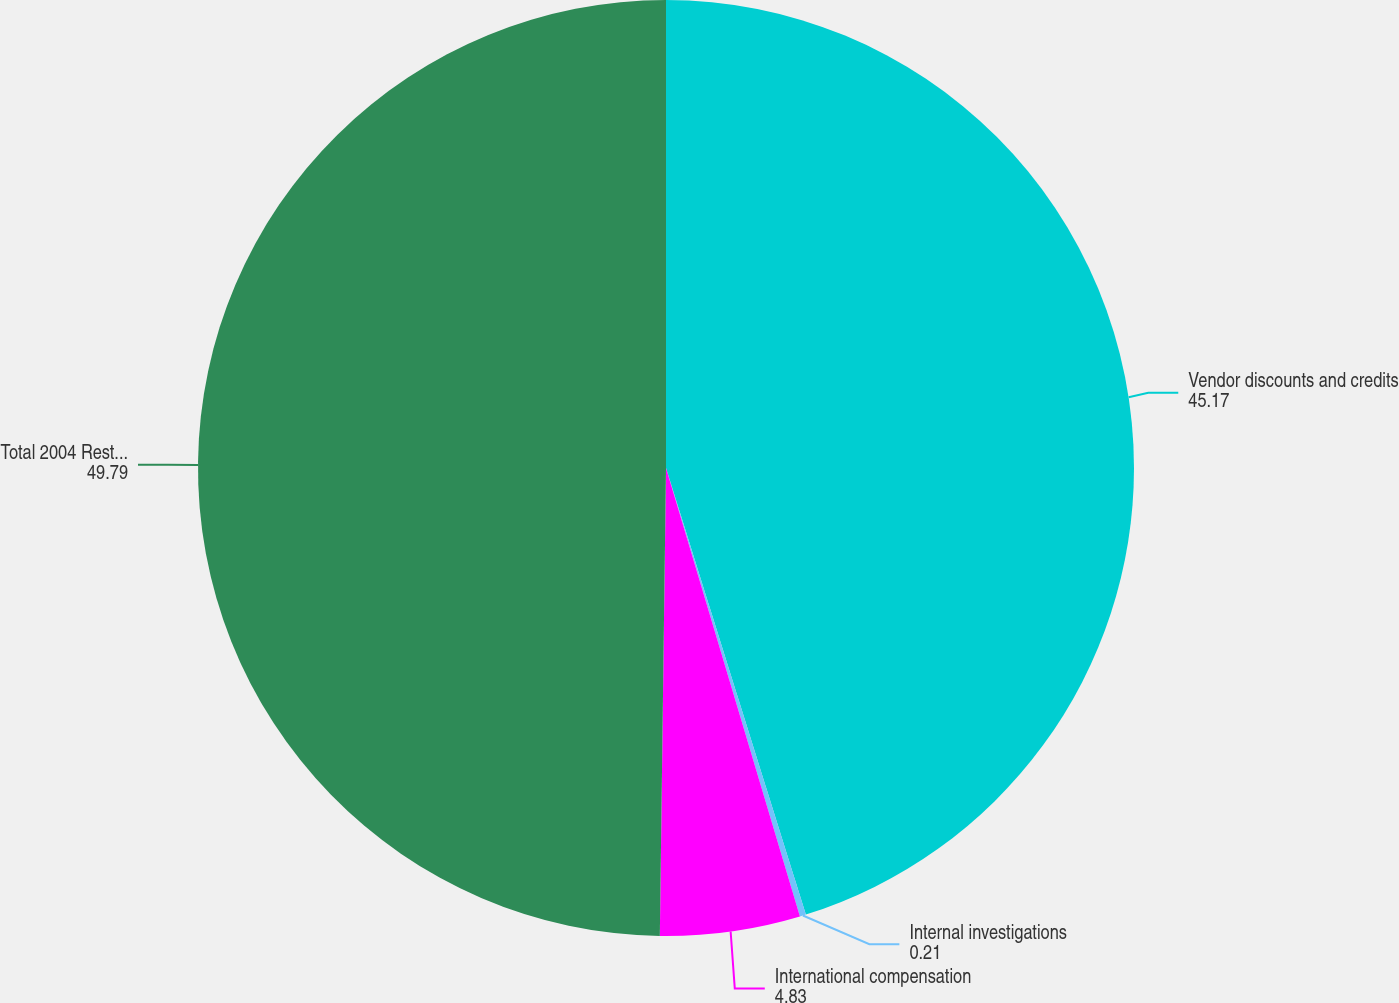Convert chart. <chart><loc_0><loc_0><loc_500><loc_500><pie_chart><fcel>Vendor discounts and credits<fcel>Internal investigations<fcel>International compensation<fcel>Total 2004 Restatement<nl><fcel>45.17%<fcel>0.21%<fcel>4.83%<fcel>49.79%<nl></chart> 